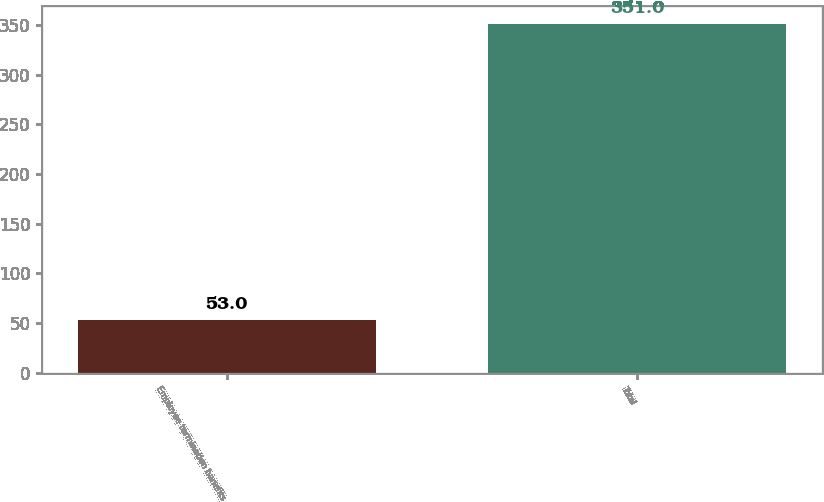Convert chart. <chart><loc_0><loc_0><loc_500><loc_500><bar_chart><fcel>Employee termination benefits<fcel>Total<nl><fcel>53<fcel>351<nl></chart> 